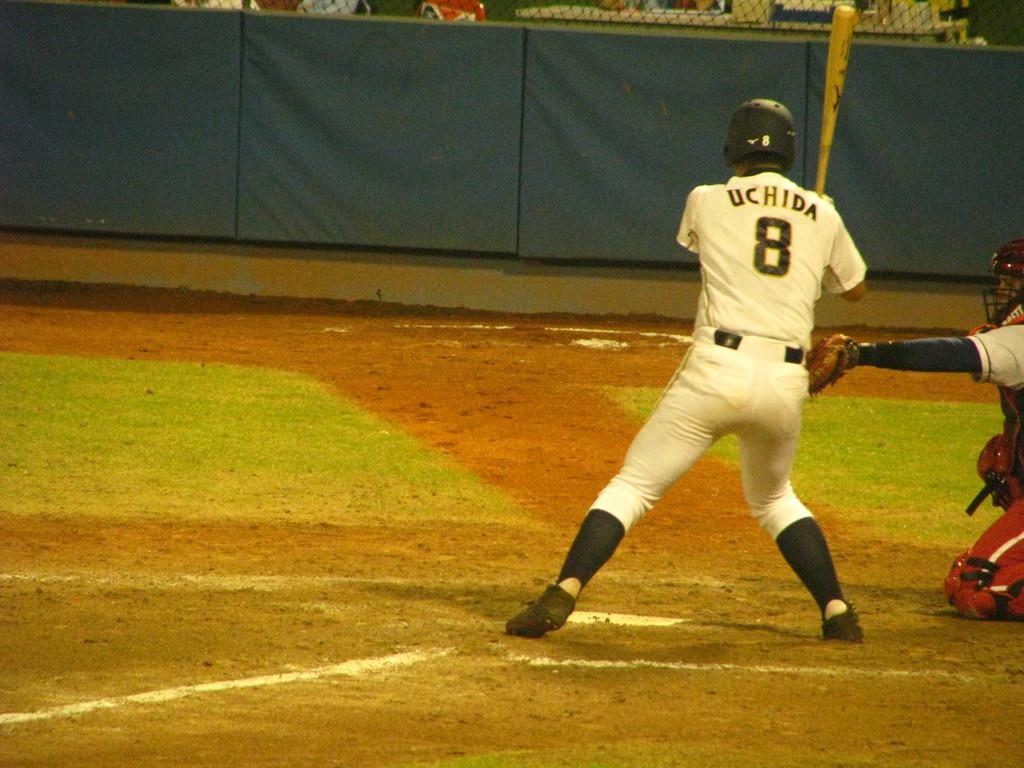<image>
Share a concise interpretation of the image provided. Baseball player getting ready to hit the ball, he is wearing #8 Uchida. 